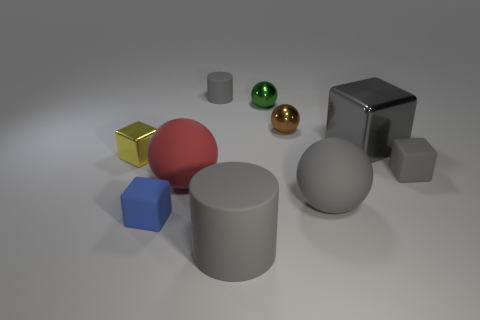Subtract all cylinders. How many objects are left? 8 Add 6 cylinders. How many cylinders exist? 8 Subtract 1 green balls. How many objects are left? 9 Subtract all tiny shiny balls. Subtract all tiny metal blocks. How many objects are left? 7 Add 1 small brown spheres. How many small brown spheres are left? 2 